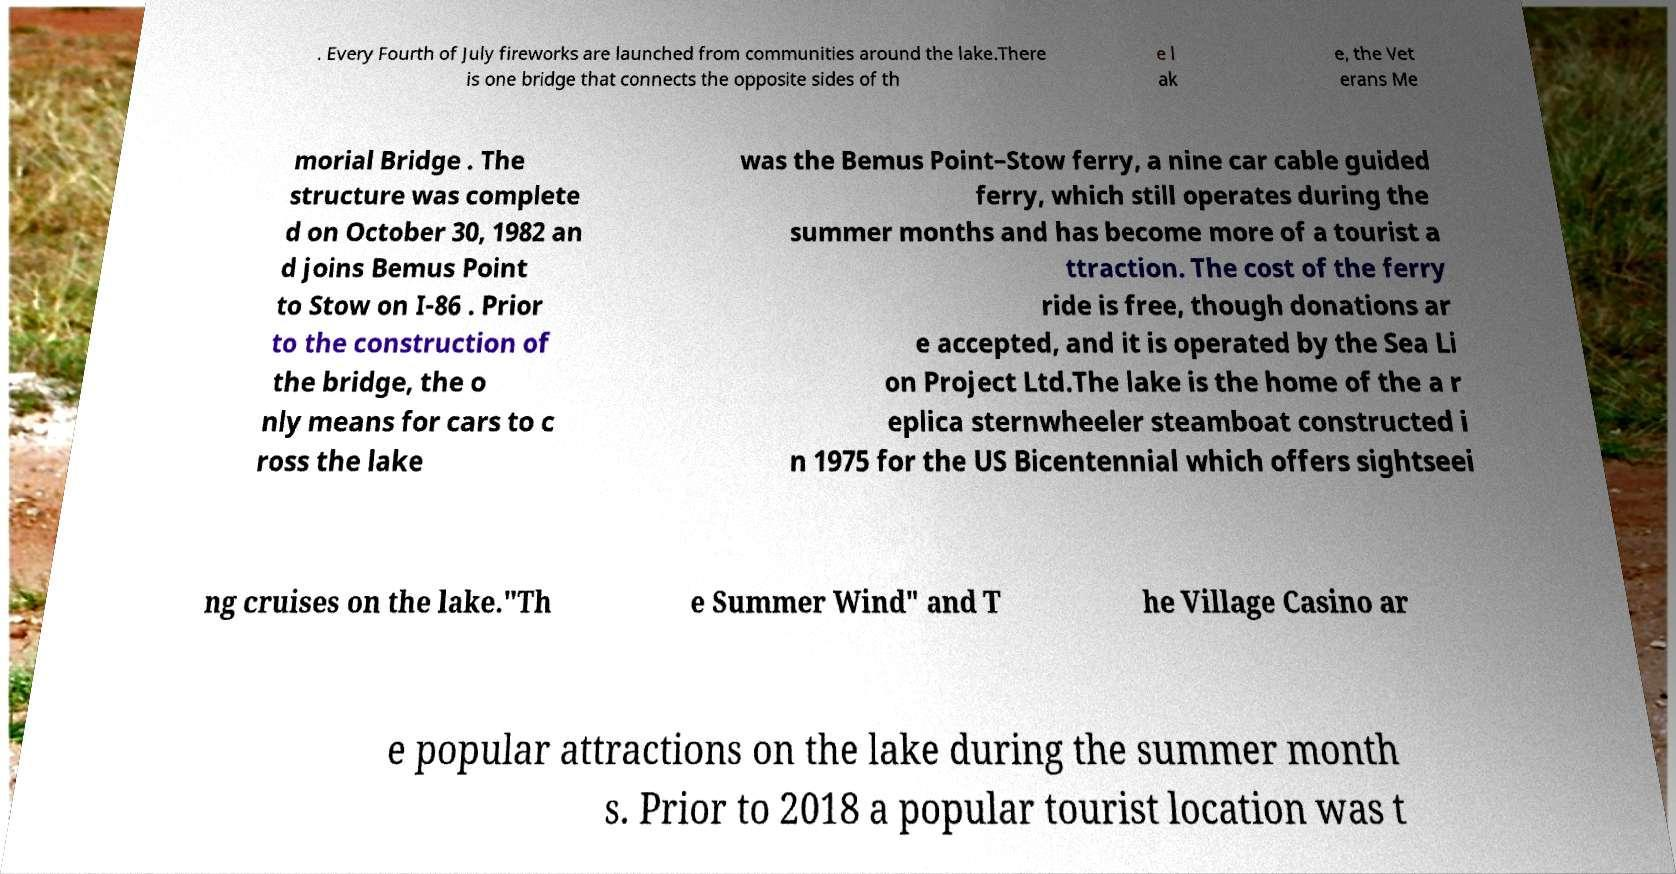There's text embedded in this image that I need extracted. Can you transcribe it verbatim? . Every Fourth of July fireworks are launched from communities around the lake.There is one bridge that connects the opposite sides of th e l ak e, the Vet erans Me morial Bridge . The structure was complete d on October 30, 1982 an d joins Bemus Point to Stow on I-86 . Prior to the construction of the bridge, the o nly means for cars to c ross the lake was the Bemus Point–Stow ferry, a nine car cable guided ferry, which still operates during the summer months and has become more of a tourist a ttraction. The cost of the ferry ride is free, though donations ar e accepted, and it is operated by the Sea Li on Project Ltd.The lake is the home of the a r eplica sternwheeler steamboat constructed i n 1975 for the US Bicentennial which offers sightseei ng cruises on the lake."Th e Summer Wind" and T he Village Casino ar e popular attractions on the lake during the summer month s. Prior to 2018 a popular tourist location was t 